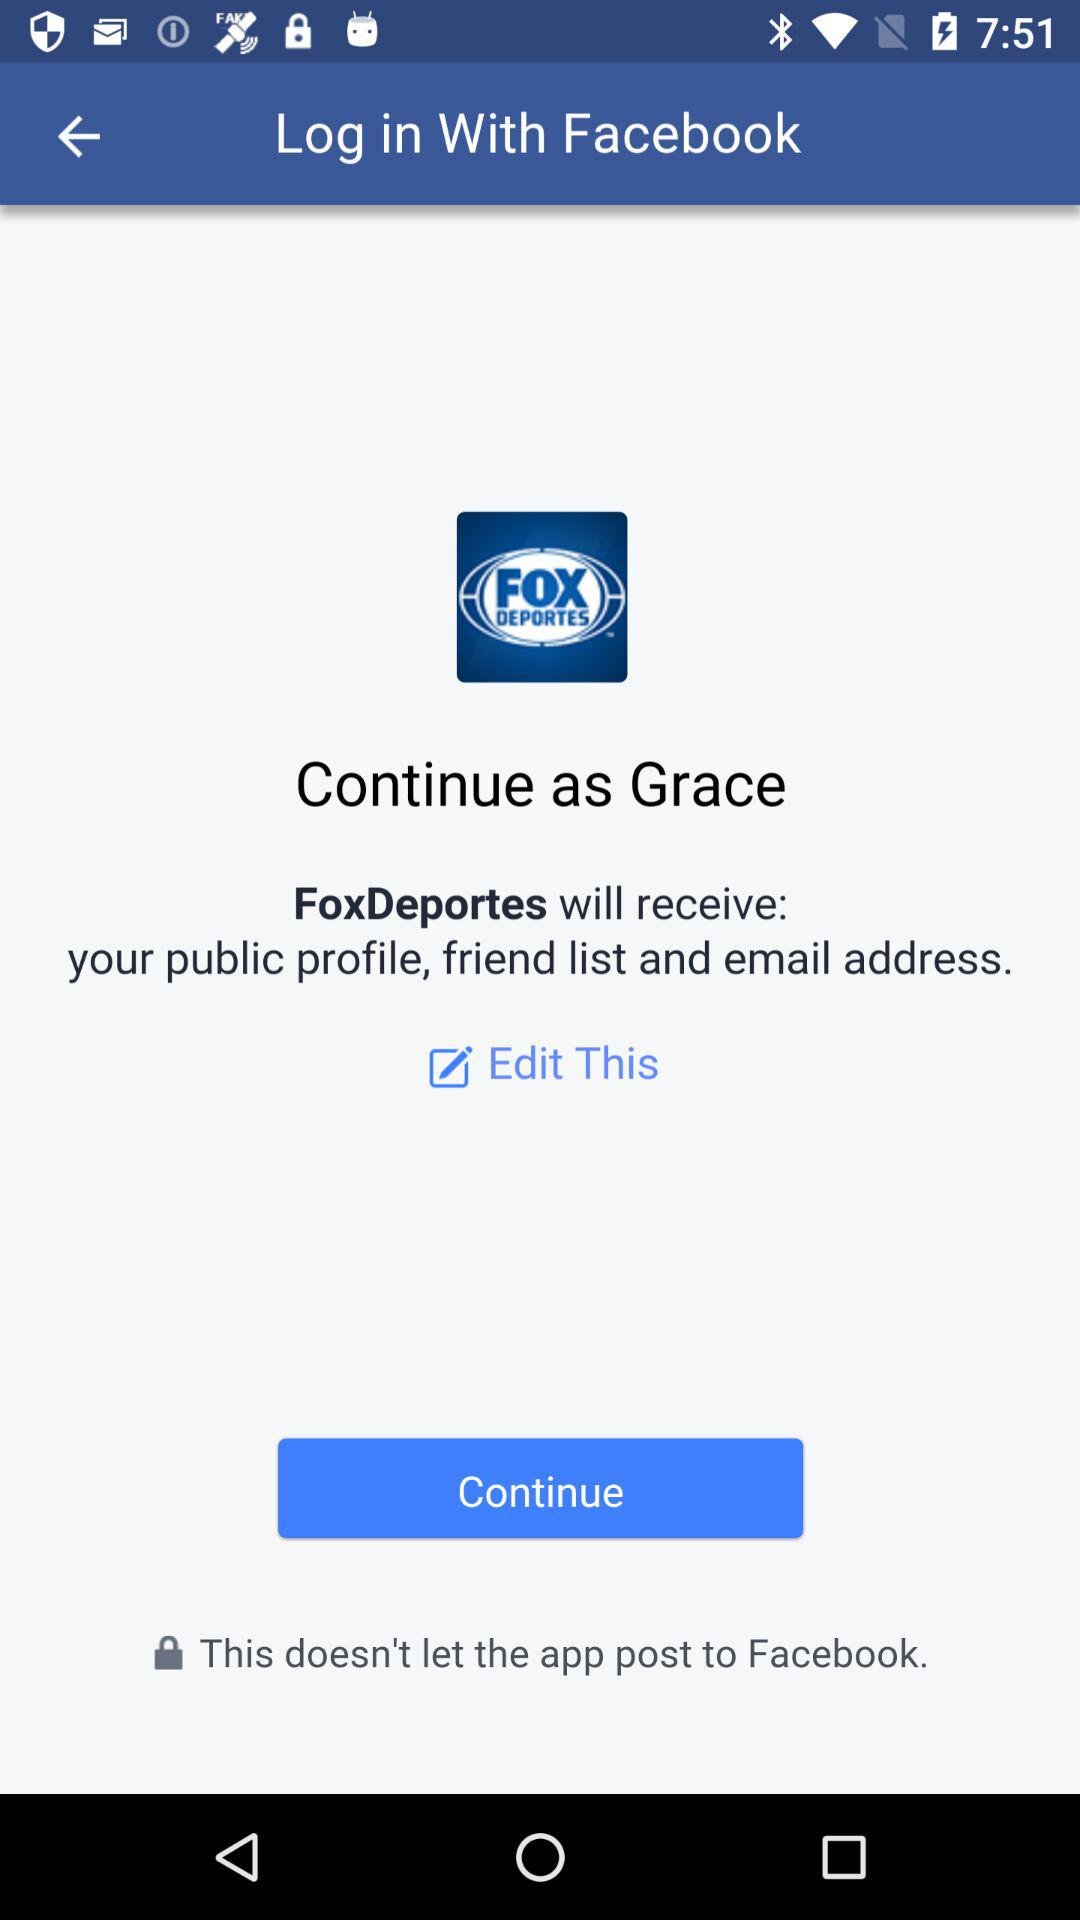What is the login name? The login name is Grace. 